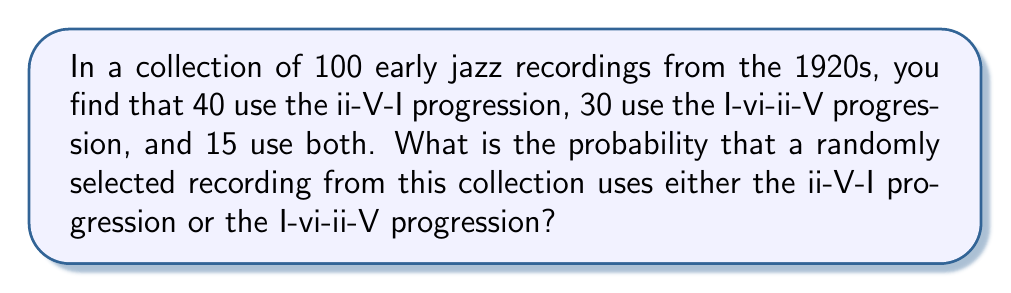Could you help me with this problem? To solve this problem, we'll use the concept of probability and set theory. Let's break it down step-by-step:

1. Define our sets:
   A = recordings with ii-V-I progression
   B = recordings with I-vi-ii-V progression

2. Given information:
   $n(A) = 40$ (number of recordings with ii-V-I)
   $n(B) = 30$ (number of recordings with I-vi-ii-V)
   $n(A \cap B) = 15$ (number of recordings with both progressions)
   Total recordings = 100

3. We need to find $P(A \cup B)$, the probability of a recording having either progression.

4. Use the addition rule of probability:
   $P(A \cup B) = P(A) + P(B) - P(A \cap B)$

5. Calculate individual probabilities:
   $P(A) = \frac{n(A)}{Total} = \frac{40}{100} = 0.4$
   $P(B) = \frac{n(B)}{Total} = \frac{30}{100} = 0.3$
   $P(A \cap B) = \frac{n(A \cap B)}{Total} = \frac{15}{100} = 0.15$

6. Apply the addition rule:
   $P(A \cup B) = 0.4 + 0.3 - 0.15 = 0.55$

Therefore, the probability of a randomly selected recording using either the ii-V-I progression or the I-vi-ii-V progression is 0.55 or 55%.
Answer: 0.55 